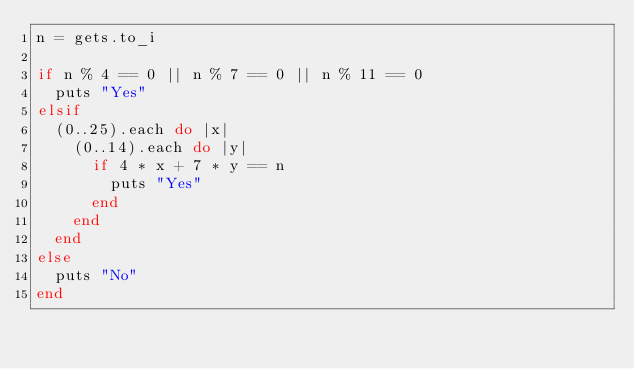Convert code to text. <code><loc_0><loc_0><loc_500><loc_500><_Ruby_>n = gets.to_i

if n % 4 == 0 || n % 7 == 0 || n % 11 == 0
  puts "Yes"
elsif
  (0..25).each do |x|
    (0..14).each do |y|
      if 4 * x + 7 * y == n
        puts "Yes"
      end
    end
  end
else
  puts "No"
end</code> 